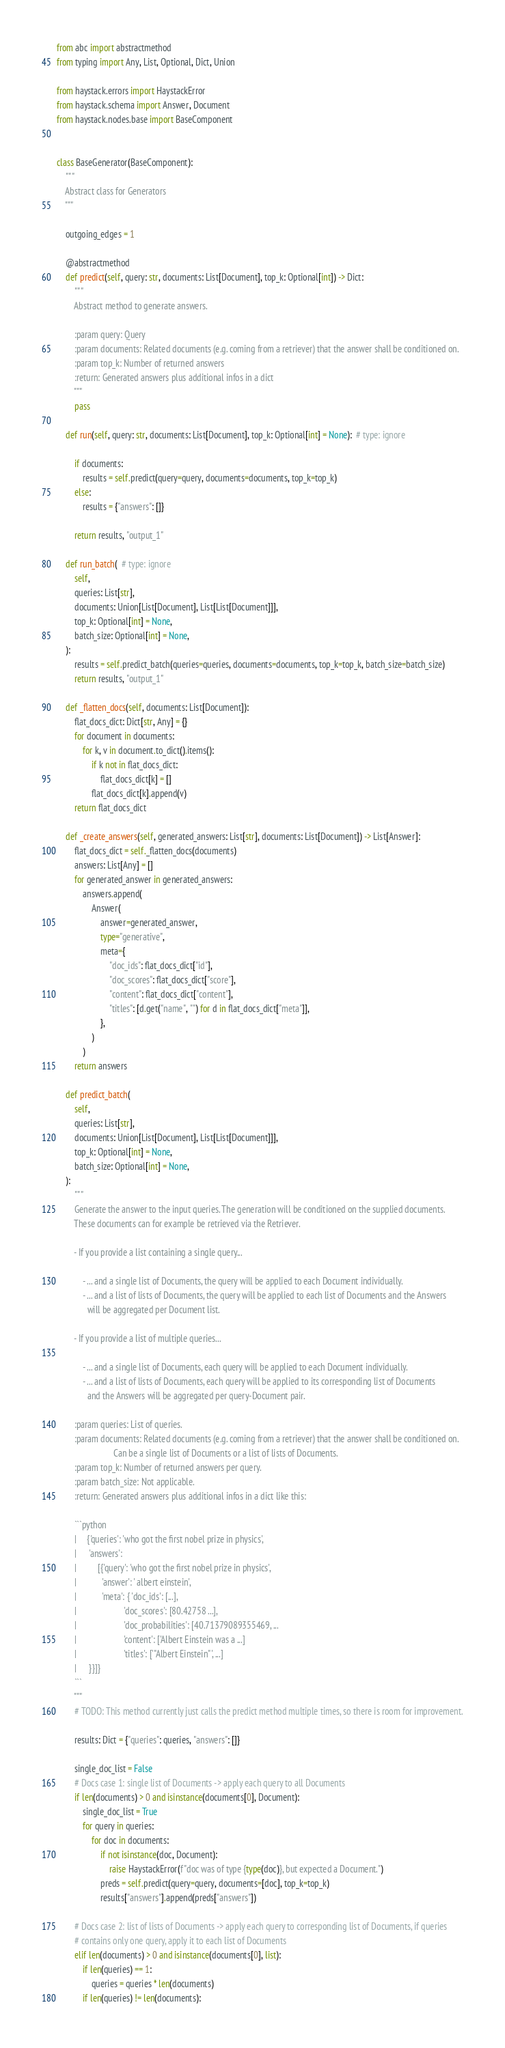Convert code to text. <code><loc_0><loc_0><loc_500><loc_500><_Python_>from abc import abstractmethod
from typing import Any, List, Optional, Dict, Union

from haystack.errors import HaystackError
from haystack.schema import Answer, Document
from haystack.nodes.base import BaseComponent


class BaseGenerator(BaseComponent):
    """
    Abstract class for Generators
    """

    outgoing_edges = 1

    @abstractmethod
    def predict(self, query: str, documents: List[Document], top_k: Optional[int]) -> Dict:
        """
        Abstract method to generate answers.

        :param query: Query
        :param documents: Related documents (e.g. coming from a retriever) that the answer shall be conditioned on.
        :param top_k: Number of returned answers
        :return: Generated answers plus additional infos in a dict
        """
        pass

    def run(self, query: str, documents: List[Document], top_k: Optional[int] = None):  # type: ignore

        if documents:
            results = self.predict(query=query, documents=documents, top_k=top_k)
        else:
            results = {"answers": []}

        return results, "output_1"

    def run_batch(  # type: ignore
        self,
        queries: List[str],
        documents: Union[List[Document], List[List[Document]]],
        top_k: Optional[int] = None,
        batch_size: Optional[int] = None,
    ):
        results = self.predict_batch(queries=queries, documents=documents, top_k=top_k, batch_size=batch_size)
        return results, "output_1"

    def _flatten_docs(self, documents: List[Document]):
        flat_docs_dict: Dict[str, Any] = {}
        for document in documents:
            for k, v in document.to_dict().items():
                if k not in flat_docs_dict:
                    flat_docs_dict[k] = []
                flat_docs_dict[k].append(v)
        return flat_docs_dict

    def _create_answers(self, generated_answers: List[str], documents: List[Document]) -> List[Answer]:
        flat_docs_dict = self._flatten_docs(documents)
        answers: List[Any] = []
        for generated_answer in generated_answers:
            answers.append(
                Answer(
                    answer=generated_answer,
                    type="generative",
                    meta={
                        "doc_ids": flat_docs_dict["id"],
                        "doc_scores": flat_docs_dict["score"],
                        "content": flat_docs_dict["content"],
                        "titles": [d.get("name", "") for d in flat_docs_dict["meta"]],
                    },
                )
            )
        return answers

    def predict_batch(
        self,
        queries: List[str],
        documents: Union[List[Document], List[List[Document]]],
        top_k: Optional[int] = None,
        batch_size: Optional[int] = None,
    ):
        """
        Generate the answer to the input queries. The generation will be conditioned on the supplied documents.
        These documents can for example be retrieved via the Retriever.

        - If you provide a list containing a single query...

            - ... and a single list of Documents, the query will be applied to each Document individually.
            - ... and a list of lists of Documents, the query will be applied to each list of Documents and the Answers
              will be aggregated per Document list.

        - If you provide a list of multiple queries...

            - ... and a single list of Documents, each query will be applied to each Document individually.
            - ... and a list of lists of Documents, each query will be applied to its corresponding list of Documents
              and the Answers will be aggregated per query-Document pair.

        :param queries: List of queries.
        :param documents: Related documents (e.g. coming from a retriever) that the answer shall be conditioned on.
                          Can be a single list of Documents or a list of lists of Documents.
        :param top_k: Number of returned answers per query.
        :param batch_size: Not applicable.
        :return: Generated answers plus additional infos in a dict like this:

        ```python
        |     {'queries': 'who got the first nobel prize in physics',
        |      'answers':
        |          [{'query': 'who got the first nobel prize in physics',
        |            'answer': ' albert einstein',
        |            'meta': { 'doc_ids': [...],
        |                      'doc_scores': [80.42758 ...],
        |                      'doc_probabilities': [40.71379089355469, ...
        |                      'content': ['Albert Einstein was a ...]
        |                      'titles': ['"Albert Einstein"', ...]
        |      }}]}
        ```
        """
        # TODO: This method currently just calls the predict method multiple times, so there is room for improvement.

        results: Dict = {"queries": queries, "answers": []}

        single_doc_list = False
        # Docs case 1: single list of Documents -> apply each query to all Documents
        if len(documents) > 0 and isinstance(documents[0], Document):
            single_doc_list = True
            for query in queries:
                for doc in documents:
                    if not isinstance(doc, Document):
                        raise HaystackError(f"doc was of type {type(doc)}, but expected a Document.")
                    preds = self.predict(query=query, documents=[doc], top_k=top_k)
                    results["answers"].append(preds["answers"])

        # Docs case 2: list of lists of Documents -> apply each query to corresponding list of Documents, if queries
        # contains only one query, apply it to each list of Documents
        elif len(documents) > 0 and isinstance(documents[0], list):
            if len(queries) == 1:
                queries = queries * len(documents)
            if len(queries) != len(documents):</code> 